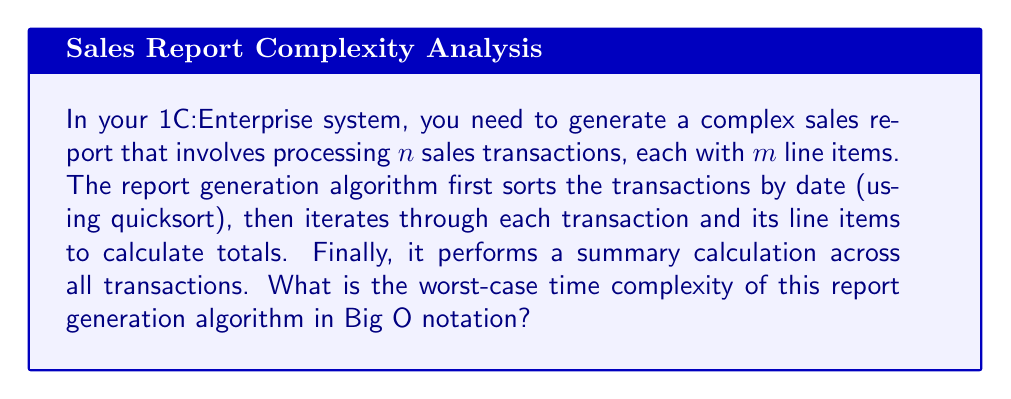Provide a solution to this math problem. Let's break down the algorithm and analyze its components:

1. Sorting transactions by date:
   The algorithm uses quicksort, which has an average-case time complexity of $O(n \log n)$, but a worst-case time complexity of $O(n^2)$ when the pivot selection is unfortunate.

2. Iterating through transactions and line items:
   This involves a nested loop structure:
   - Outer loop: iterates through $n$ transactions
   - Inner loop: processes $m$ line items for each transaction
   The time complexity for this part is $O(n \cdot m)$

3. Summary calculation:
   This final step involves going through all transactions once more, which has a time complexity of $O(n)$

To determine the overall worst-case time complexity, we need to sum up these components:

$$ T(n,m) = O(n^2) + O(n \cdot m) + O(n) $$

Simplifying this expression:

1. $O(n^2)$ dominates $O(n)$, so we can drop the $O(n)$ term
2. We need to compare $O(n^2)$ and $O(n \cdot m)$

The worst-case scenario occurs when $m \geq n$, as this makes $O(n \cdot m)$ at least as significant as $O(n^2)$. In this case, $O(n \cdot m)$ would dominate.

Therefore, the worst-case time complexity is:

$$ O(n \cdot m) $$

This reflects that in the worst case, the time complexity grows linearly with both the number of transactions and the number of line items per transaction.
Answer: $O(n \cdot m)$, where $n$ is the number of transactions and $m$ is the number of line items per transaction. 